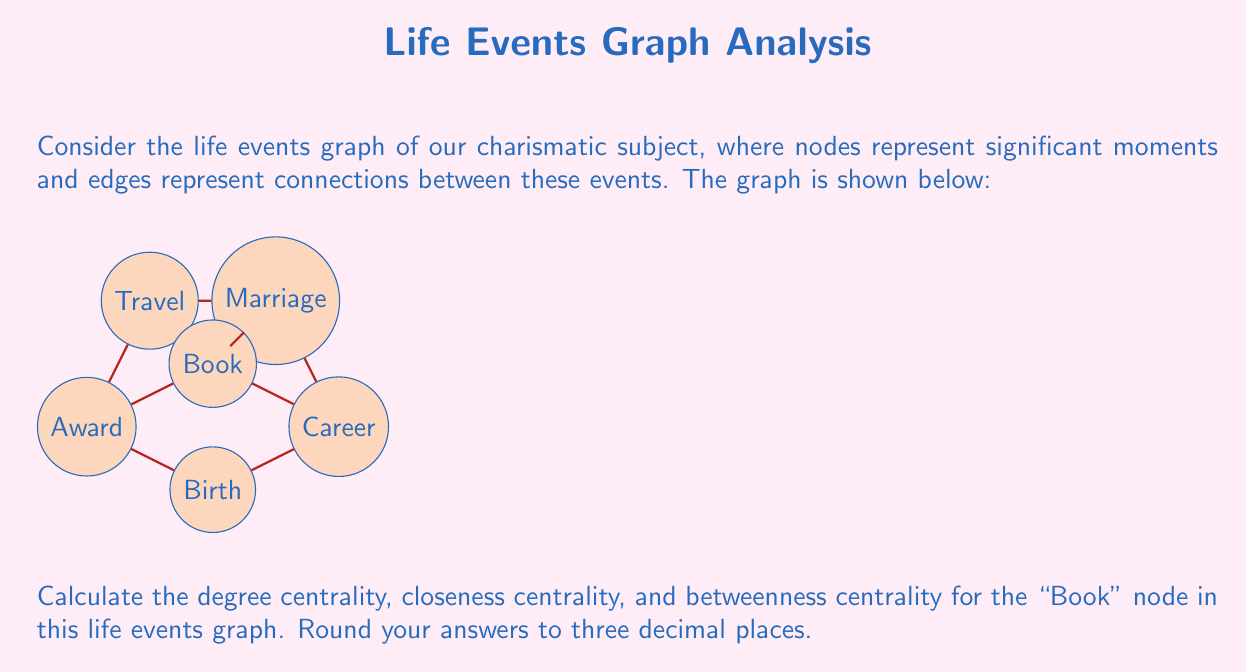What is the answer to this math problem? Let's calculate each centrality measure for the "Book" node:

1. Degree Centrality:
   Degree centrality is the number of edges connected to a node, normalized by the maximum possible degree.
   - The "Book" node has 3 connections (Career, Marriage, Award).
   - There are 6 nodes in total, so the maximum possible degree is 5.
   - Degree Centrality = $\frac{3}{5} = 0.600$

2. Closeness Centrality:
   Closeness centrality measures how close a node is to all other nodes in the graph.
   - Calculate the shortest path from "Book" to all other nodes:
     Book to Birth: 2, Career: 1, Marriage: 1, Travel: 2, Award: 1
   - Sum of shortest paths: 2 + 1 + 1 + 2 + 1 = 7
   - Closeness Centrality = $\frac{n-1}{\text{sum of shortest paths}} = \frac{5}{7} \approx 0.714$

3. Betweenness Centrality:
   Betweenness centrality measures how often a node appears on the shortest paths between other nodes.
   - Count the number of shortest paths that pass through "Book":
     Birth to Marriage: 1 out of 1
     Birth to Travel: 0 out of 2
     Career to Award: 1 out of 2
     Career to Travel: 1 out of 1
     Marriage to Award: 1 out of 1
   - Sum of fractions: 1 + 0 + 0.5 + 1 + 1 = 3.5
   - Normalize by dividing by the number of possible pairs: $\frac{(n-1)(n-2)}{2} = 10$
   - Betweenness Centrality = $\frac{3.5}{10} = 0.350$
Answer: Degree Centrality: 0.600, Closeness Centrality: 0.714, Betweenness Centrality: 0.350 